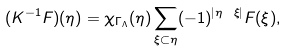Convert formula to latex. <formula><loc_0><loc_0><loc_500><loc_500>( K ^ { - 1 } F ) ( \eta ) = \chi _ { \Gamma _ { \Lambda } } ( \eta ) \sum _ { \xi \subset \eta } ( - 1 ) ^ { | \eta \ \xi | } F ( \xi ) ,</formula> 